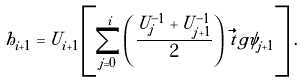Convert formula to latex. <formula><loc_0><loc_0><loc_500><loc_500>h _ { i + 1 } = U _ { i + 1 } \left [ \sum _ { j = 0 } ^ { i } \left ( \frac { U _ { j } ^ { - 1 } + U _ { j + 1 } ^ { - 1 } } { 2 } \right ) \, \vec { t } g { \psi } _ { j + 1 } \right ] \, .</formula> 